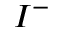Convert formula to latex. <formula><loc_0><loc_0><loc_500><loc_500>I ^ { - }</formula> 